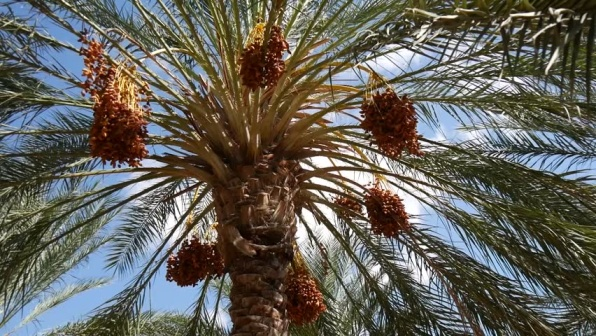What are some uses of the dates produced by this palm tree? Dates from the palm tree, like the one depicted, are incredibly versatile. They are frequently eaten raw, offering a sweet, rich flavor. In cooking, they are used in a variety of dishes, from desserts like maamoul and date squares to savory recipes like tagines or stuffed with almonds or cream cheese. Nutritionally, they are a significant source of fiber, sugars, and minerals such as potassium and magnesium. How do the agricultural practices affect the growth of these date palms? Adequate irrigation and sunlight are crucial for the growth of date palms, especially given their preference for arid environments. Farmers often engage in practices like thinning, which involves removing some fruits to allow ample resources for the remaining dates to grow larger and richer. Moreover, keeping the area around the trees clear of weeds and other plants ensures that the nutrients in the soil are preserved for the palm's growth. 